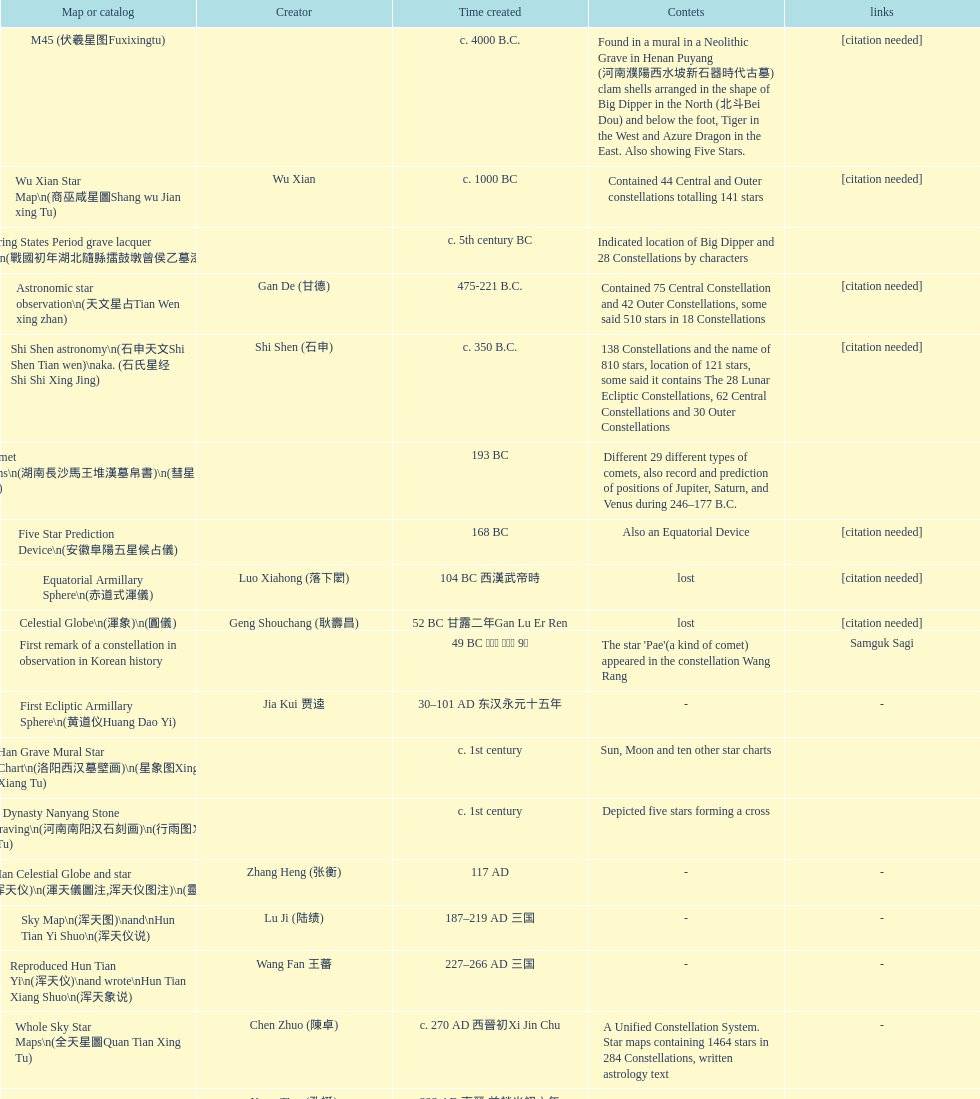At what point in time was the first map or catalog made? C. 4000 b.c. 